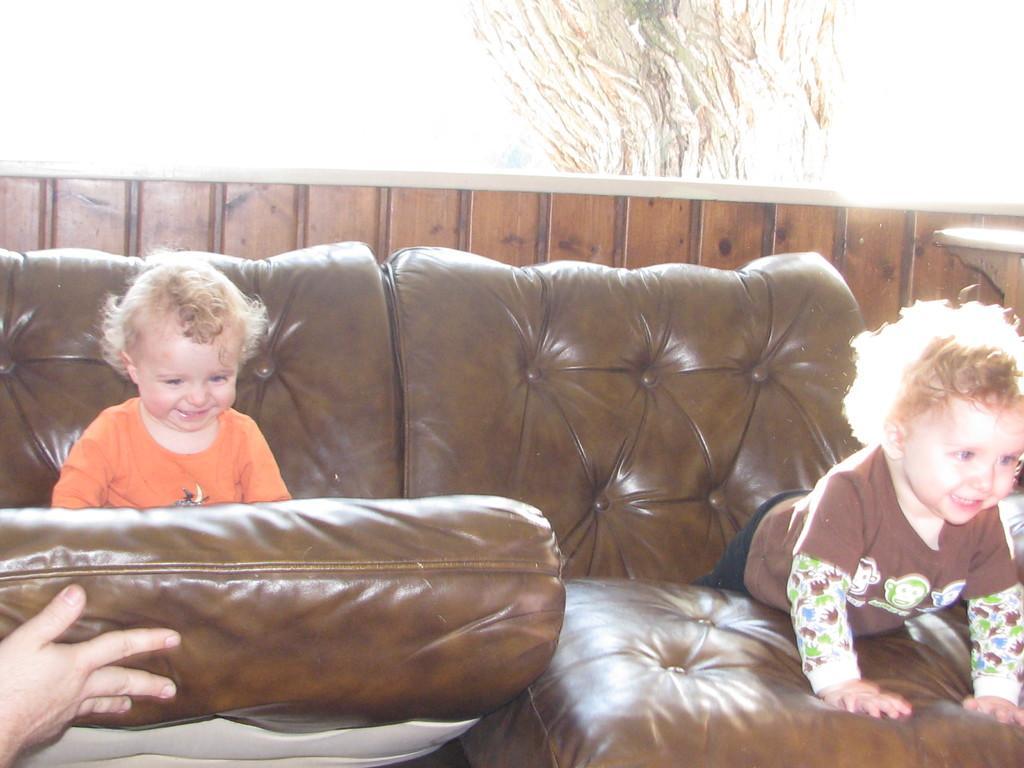Describe this image in one or two sentences. In this picture we can see a couch and two baby they are playing on the couch and one hand is holding the couch. 